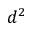<formula> <loc_0><loc_0><loc_500><loc_500>d ^ { 2 }</formula> 